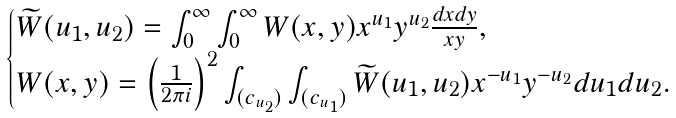<formula> <loc_0><loc_0><loc_500><loc_500>\begin{cases} \widetilde { W } ( u _ { 1 } , u _ { 2 } ) = \int _ { 0 } ^ { \infty } \int _ { 0 } ^ { \infty } W ( x , y ) x ^ { u _ { 1 } } y ^ { u _ { 2 } } \frac { d x d y } { x y } , \\ W ( x , y ) = \left ( \frac { 1 } { 2 \pi i } \right ) ^ { 2 } \int _ { ( c _ { u _ { 2 } } ) } \int _ { ( c _ { u _ { 1 } } ) } \widetilde { W } ( u _ { 1 } , u _ { 2 } ) x ^ { - u _ { 1 } } y ^ { - u _ { 2 } } d u _ { 1 } d u _ { 2 } . \end{cases}</formula> 